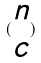<formula> <loc_0><loc_0><loc_500><loc_500>( \begin{matrix} n \\ c \end{matrix} )</formula> 